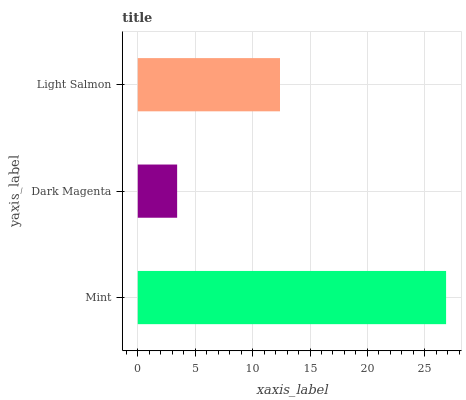Is Dark Magenta the minimum?
Answer yes or no. Yes. Is Mint the maximum?
Answer yes or no. Yes. Is Light Salmon the minimum?
Answer yes or no. No. Is Light Salmon the maximum?
Answer yes or no. No. Is Light Salmon greater than Dark Magenta?
Answer yes or no. Yes. Is Dark Magenta less than Light Salmon?
Answer yes or no. Yes. Is Dark Magenta greater than Light Salmon?
Answer yes or no. No. Is Light Salmon less than Dark Magenta?
Answer yes or no. No. Is Light Salmon the high median?
Answer yes or no. Yes. Is Light Salmon the low median?
Answer yes or no. Yes. Is Dark Magenta the high median?
Answer yes or no. No. Is Dark Magenta the low median?
Answer yes or no. No. 